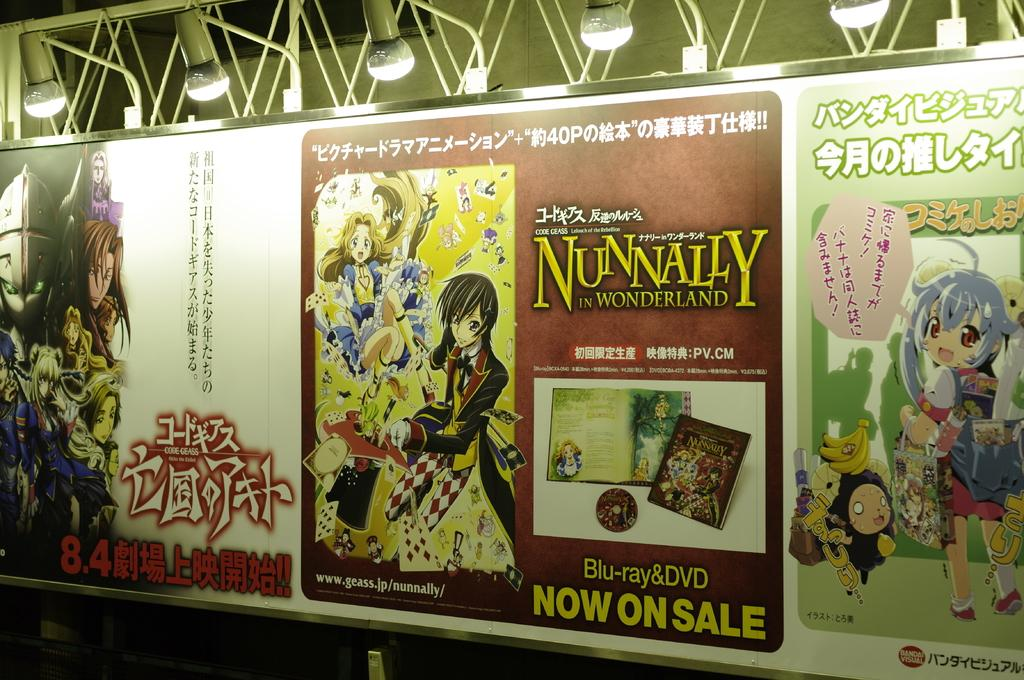<image>
Write a terse but informative summary of the picture. Posters for Japanese programs like Nunnally in Wonderland 